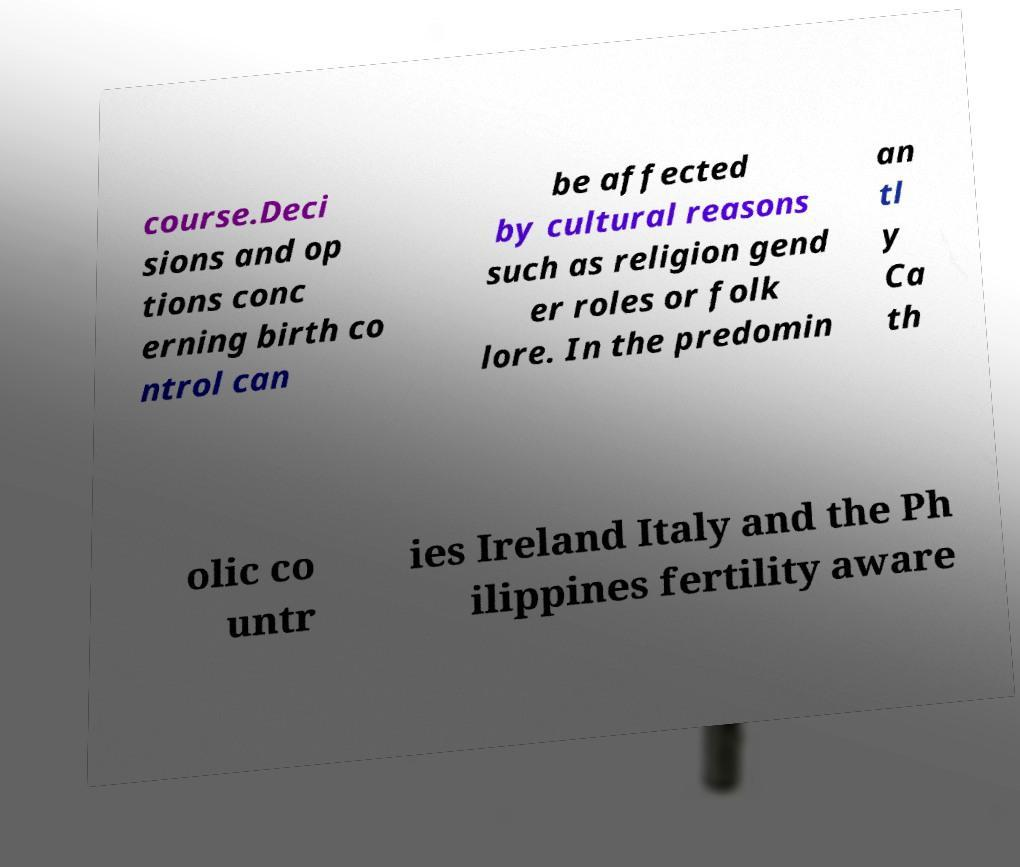Could you assist in decoding the text presented in this image and type it out clearly? course.Deci sions and op tions conc erning birth co ntrol can be affected by cultural reasons such as religion gend er roles or folk lore. In the predomin an tl y Ca th olic co untr ies Ireland Italy and the Ph ilippines fertility aware 